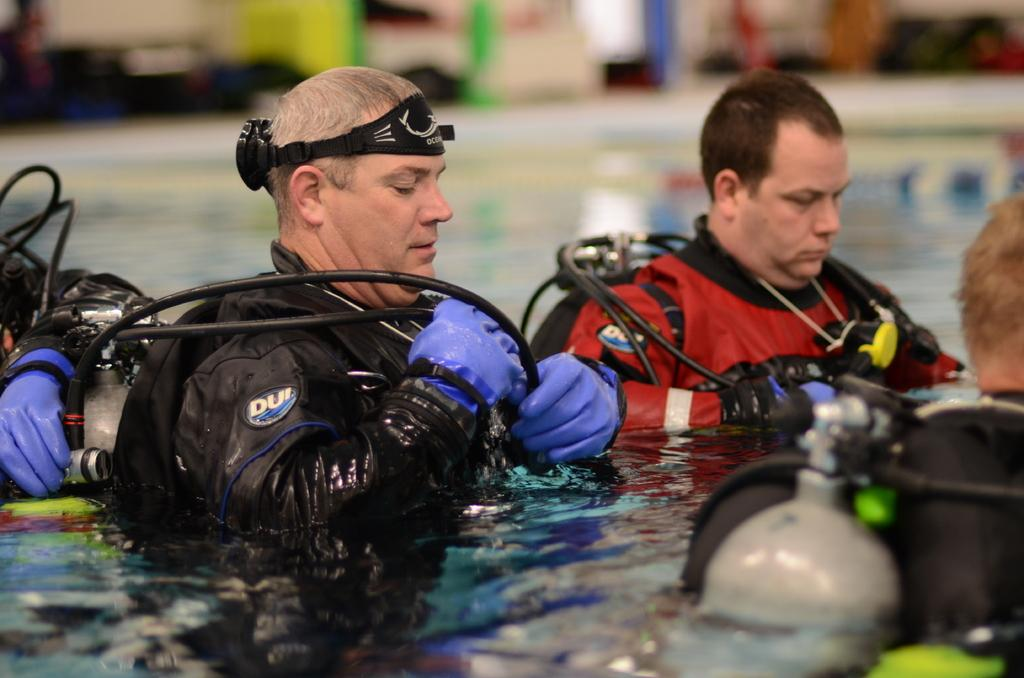How many people are in the image? There are four people in the image. What are the people doing in the image? The people are standing in the water. What can be inferred about the gender of the people in the image? All the people are men. What are the men wearing in the image? The men are wearing jackets. What are the men carrying in the image? The men are carrying gas cylinders. How many beds can be seen in the image? There are no beds present in the image. Is there a cellar visible in the image? There is no cellar visible in the image. 